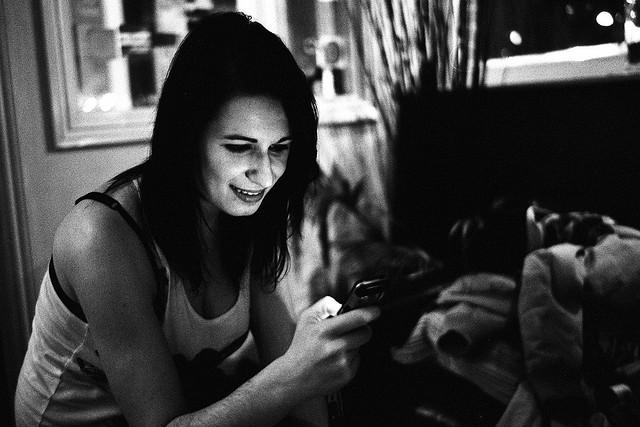Does the woman have earrings?
Keep it brief. No. How many people are on their phones?
Write a very short answer. 1. Is the woman wearing lingerie?
Short answer required. No. Is the lady waiting to be picked up?
Answer briefly. No. Is the woman sad?
Be succinct. No. About how old is the girl?
Write a very short answer. 25. Is the woman wearing jewelry?
Keep it brief. No. Is her hair straight?
Quick response, please. Yes. What is she looking at?
Quick response, please. Phone. What type of top is the woman wearing?
Answer briefly. Tank top. 